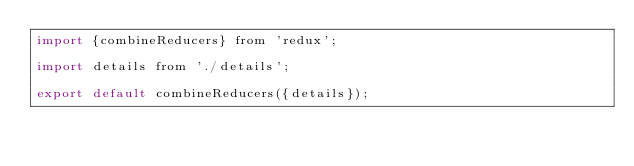<code> <loc_0><loc_0><loc_500><loc_500><_JavaScript_>import {combineReducers} from 'redux';

import details from './details';

export default combineReducers({details});
</code> 